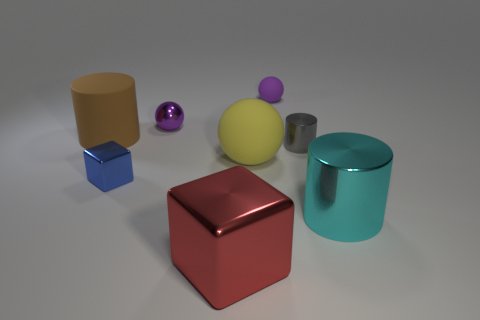Can you describe the scene depicted in the image? The image portrays a collection of geometric shapes and objects with glossy surfaces, placed seemingly randomly on a flat surface. The assortment includes cylinders, spheres, and cubes of various colors, each demonstrating different reflective properties under a uniform light source. 